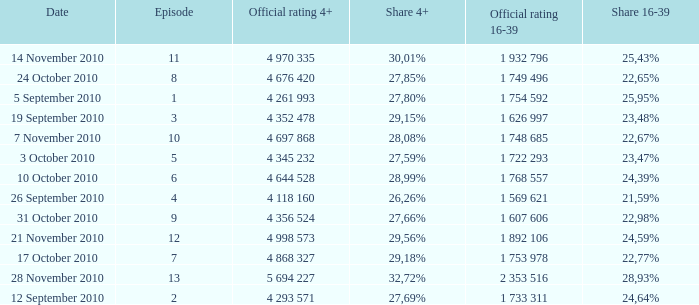What is the 16-39 share of the episode with a 4+ share of 30,01%? 25,43%. 